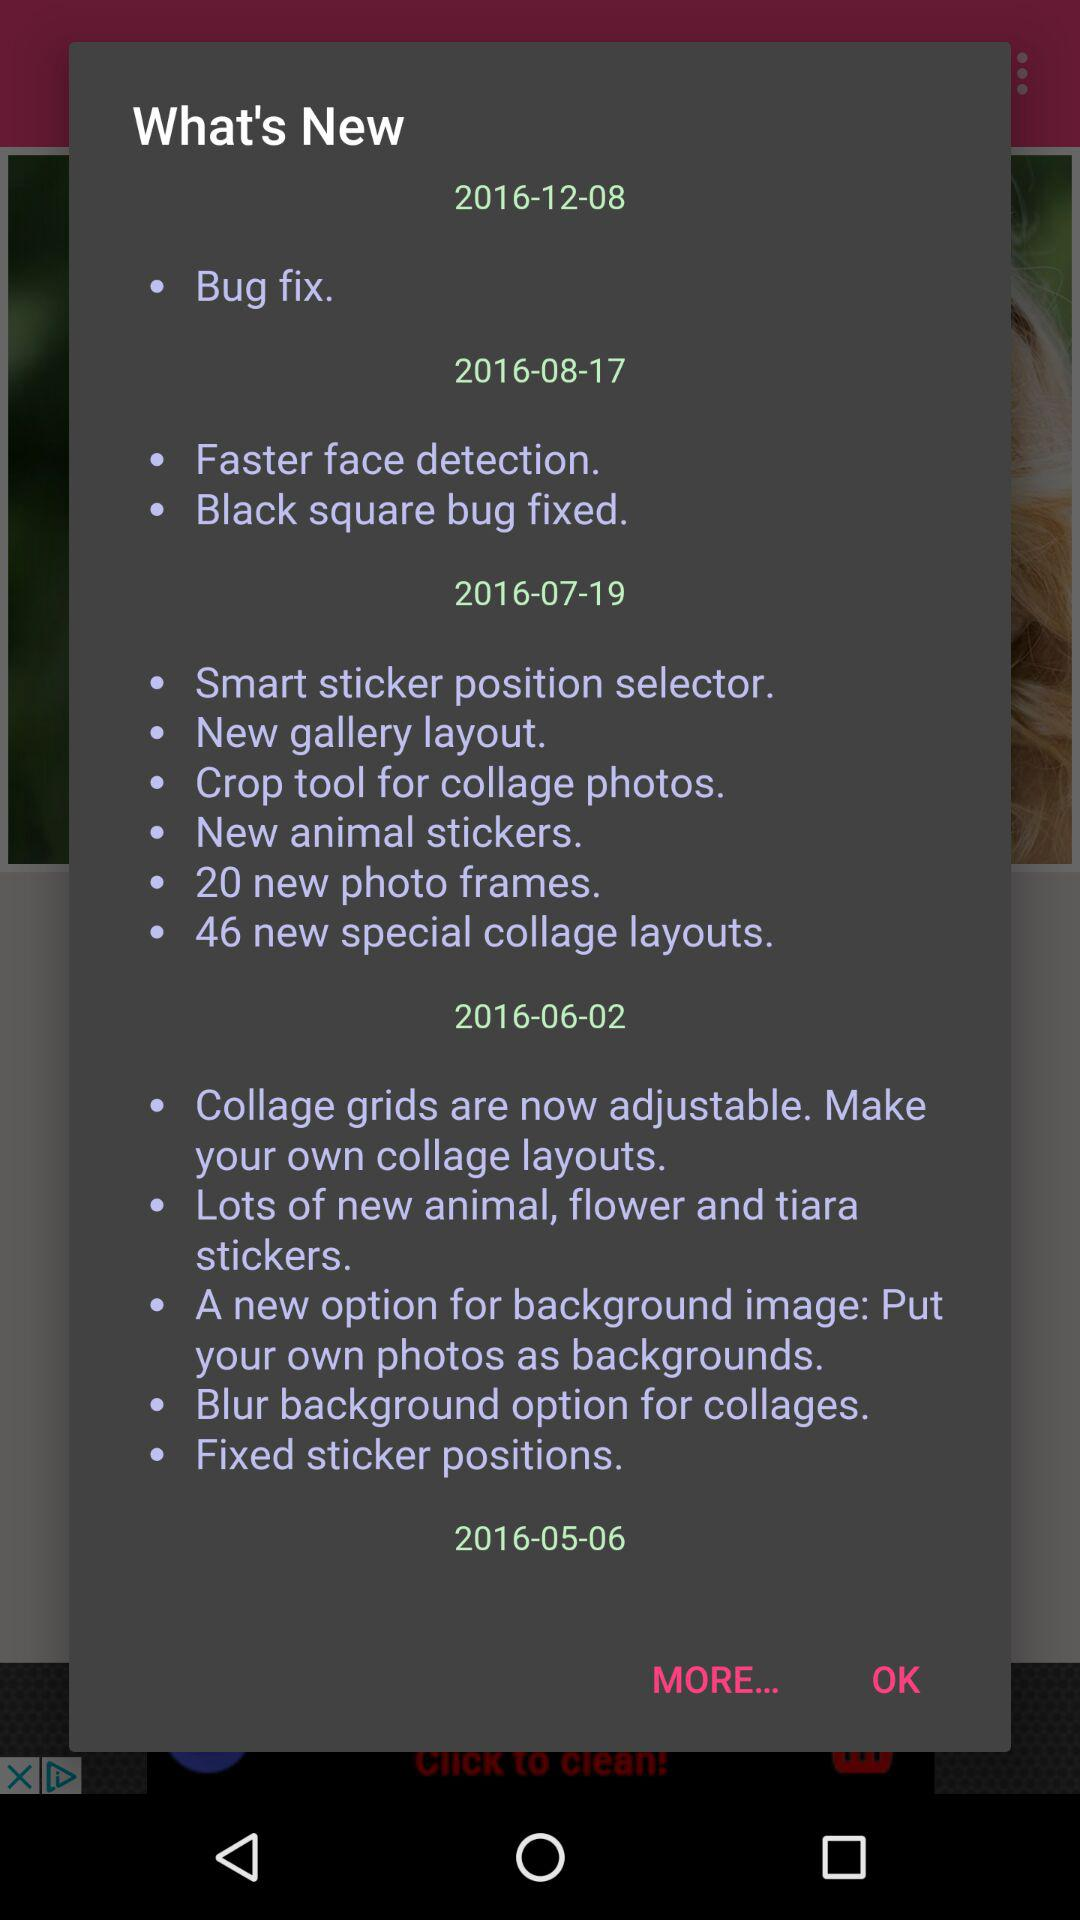What is the number of photo frames? The number of photo frames is 20. 